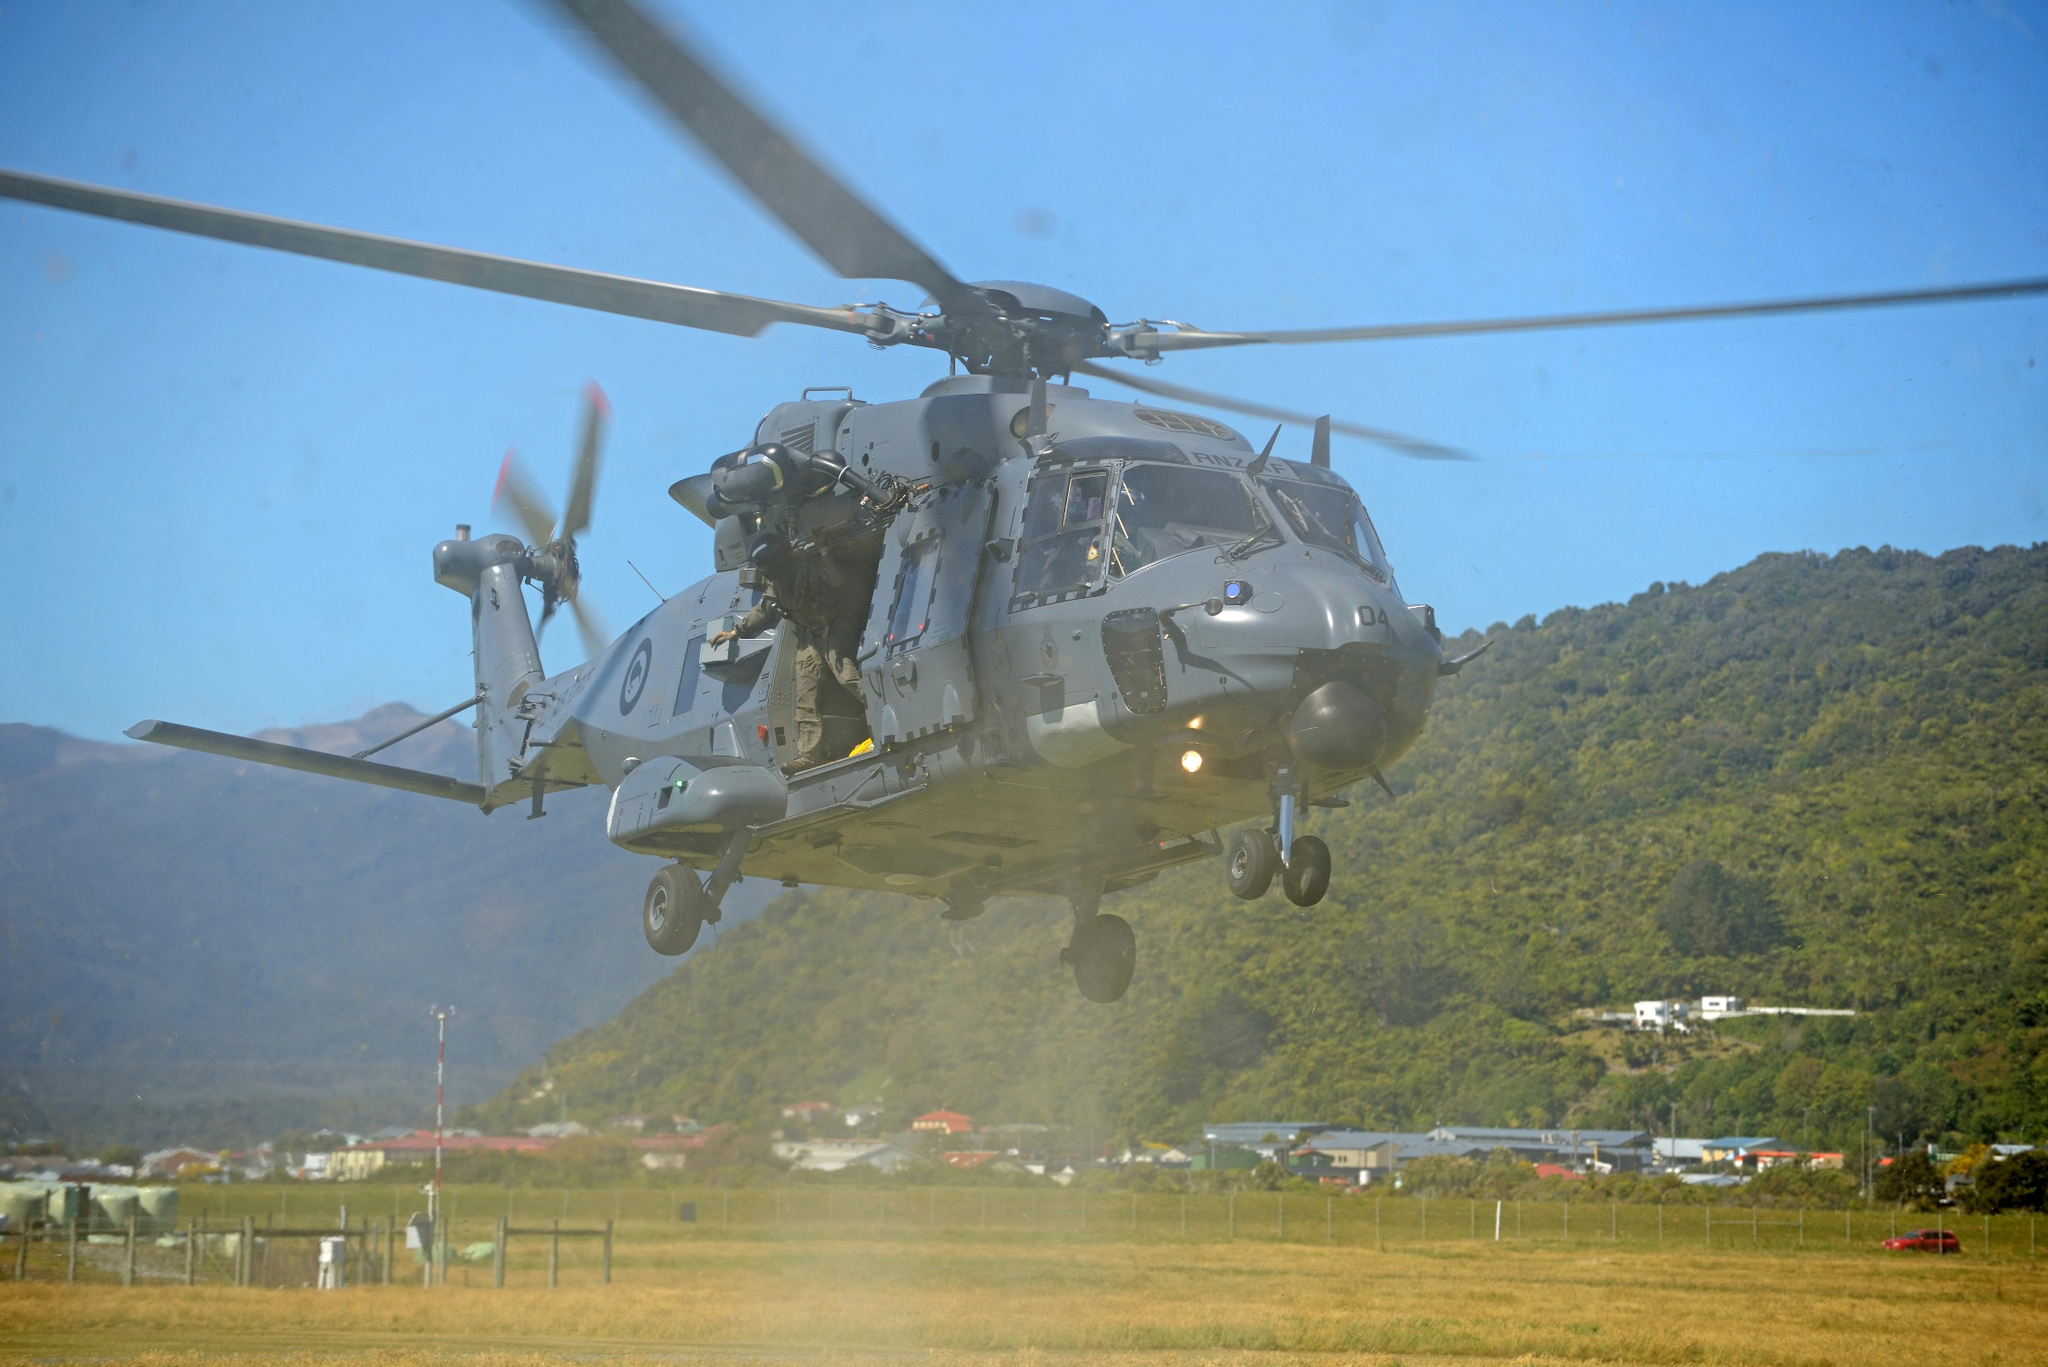What kind of training might the crew be undergoing? The crew might be undergoing combat readiness training, focusing on operational disciplines such as tactical flying, precision maneuvering, search and rescue operations, and rapid response drills. This could include navigating through diverse terrains, engaging in simulated combat scenarios, or performing rescue missions under varying conditions to ensure preparedness for actual field operations. Can you expand on the potential technological systems onboard this helicopter? Absolutely! Modern military helicopters often come equipped with advanced technological systems. These can include state-of-the-art avionics for navigation and communication, infrared and night vision systems for low visibility operations, and sophisticated radar and sensor arrays for detecting and tracking targets. Additionally, the helicopter might feature advanced weaponry systems, electronic countermeasures for defense, and rescue equipment for search and rescue missions. Let's think creatively: What if this helicopter was participating in a humanitarian mission in a fantastic, magical realm? Imagine this helicopter soaring through a mystical landscape, where towering, crystalline structures rise from the earth and bioluminescent flora illuminate the night. The crew is on a noble humanitarian mission, delivering supplies to a hidden village of peaceful sorcerers besieged by dark forces. The helicopter, modified with magical runes, can cloak itself from enemy sight and traverse enchanted forests. As it flies over enchanted rivers and bewitched mountains, the crew remains vigilant, for in this realm, danger could come from both the skies and the ground, where mythical creatures and enchanted adversaries lurk. 